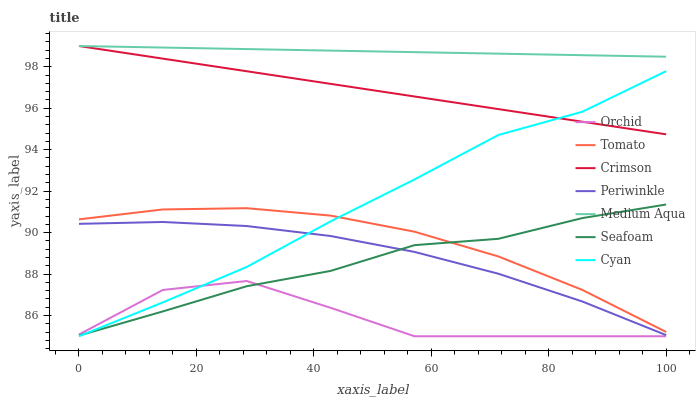Does Orchid have the minimum area under the curve?
Answer yes or no. Yes. Does Medium Aqua have the maximum area under the curve?
Answer yes or no. Yes. Does Seafoam have the minimum area under the curve?
Answer yes or no. No. Does Seafoam have the maximum area under the curve?
Answer yes or no. No. Is Crimson the smoothest?
Answer yes or no. Yes. Is Orchid the roughest?
Answer yes or no. Yes. Is Seafoam the smoothest?
Answer yes or no. No. Is Seafoam the roughest?
Answer yes or no. No. Does Cyan have the lowest value?
Answer yes or no. Yes. Does Seafoam have the lowest value?
Answer yes or no. No. Does Crimson have the highest value?
Answer yes or no. Yes. Does Seafoam have the highest value?
Answer yes or no. No. Is Tomato less than Medium Aqua?
Answer yes or no. Yes. Is Tomato greater than Periwinkle?
Answer yes or no. Yes. Does Crimson intersect Cyan?
Answer yes or no. Yes. Is Crimson less than Cyan?
Answer yes or no. No. Is Crimson greater than Cyan?
Answer yes or no. No. Does Tomato intersect Medium Aqua?
Answer yes or no. No. 